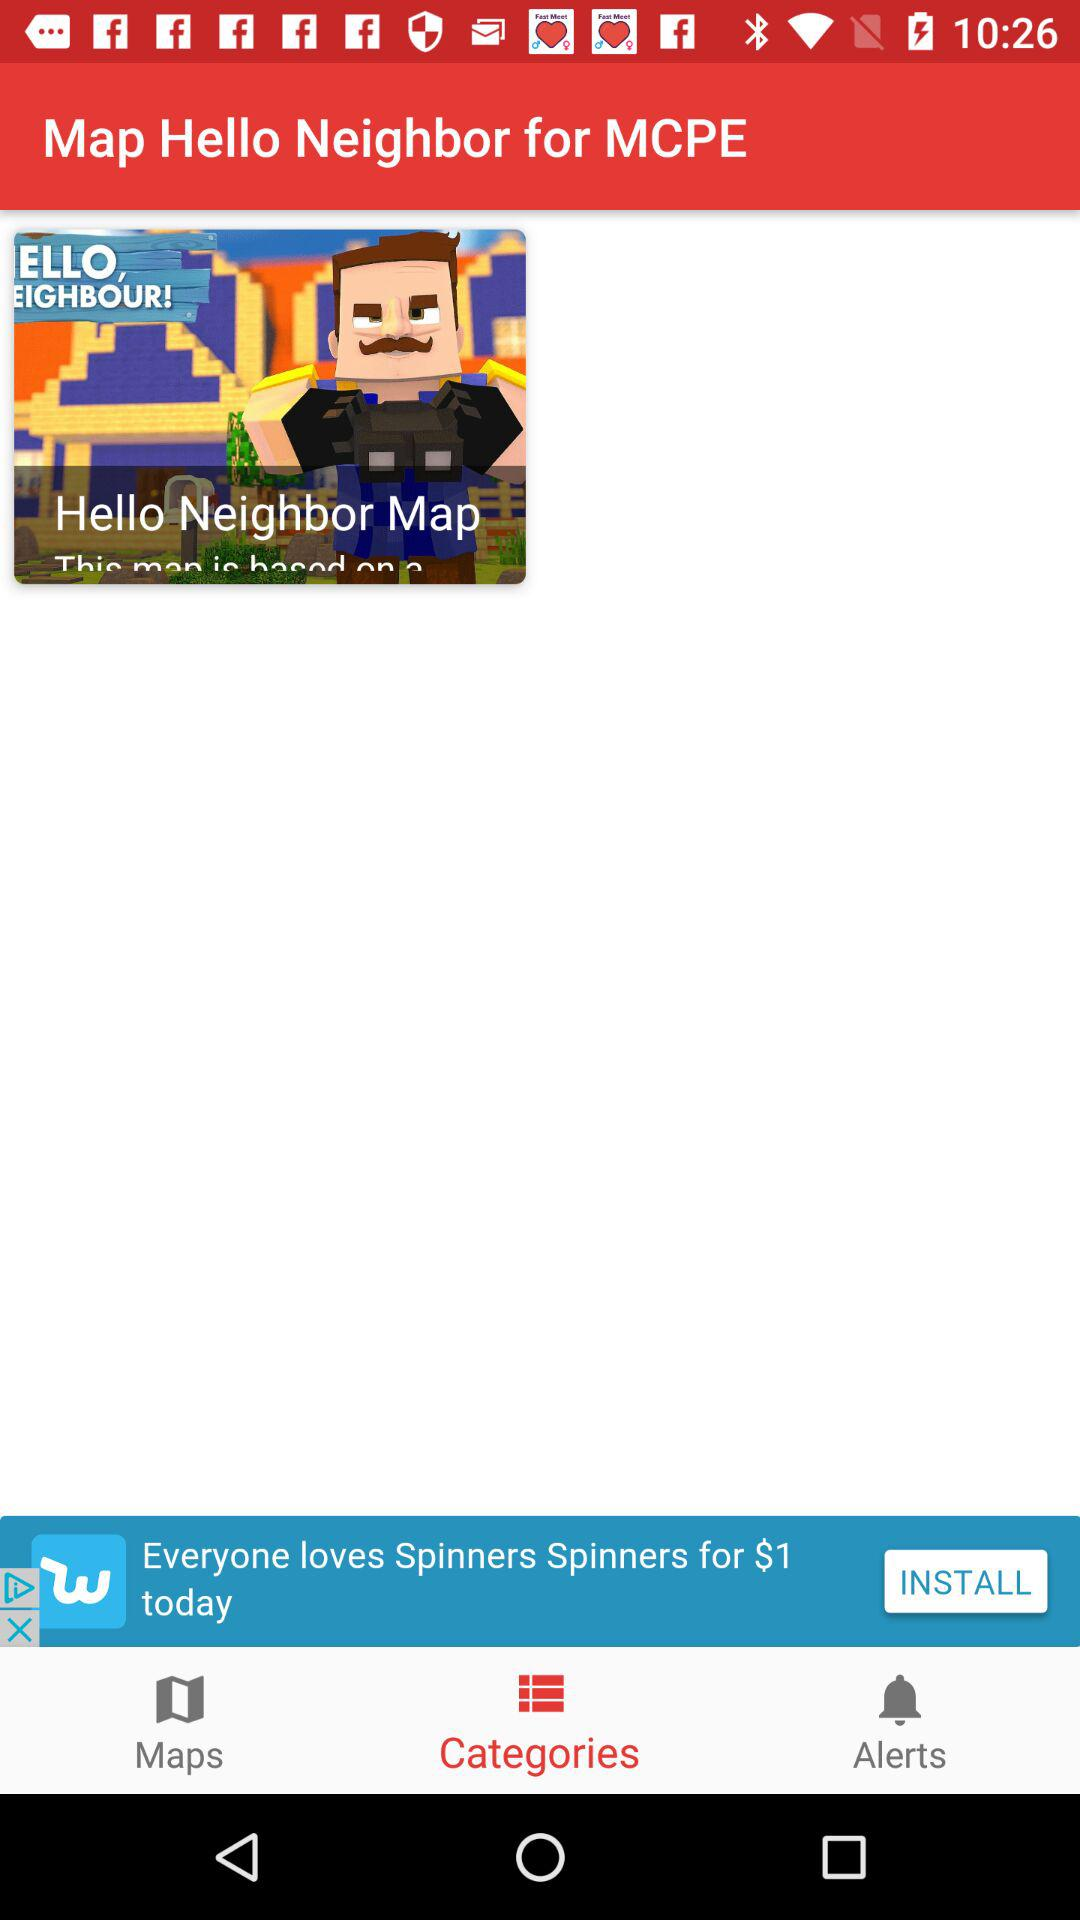What is the selected tab? The selected tab is "Categories". 